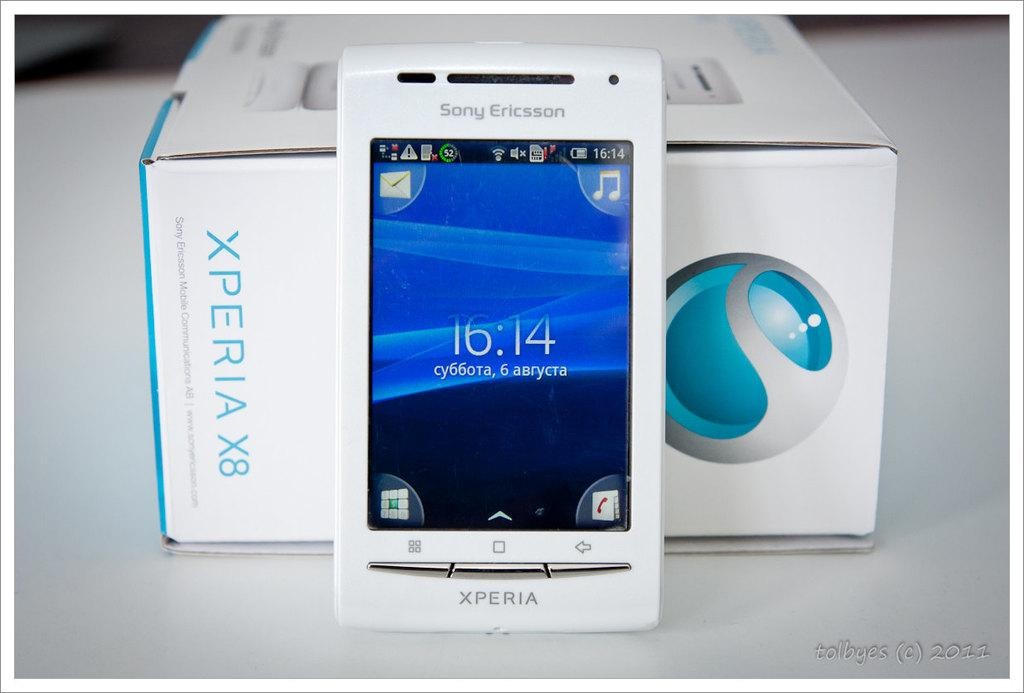<image>
Present a compact description of the photo's key features. a phone that has the numbers 16:14 on it 